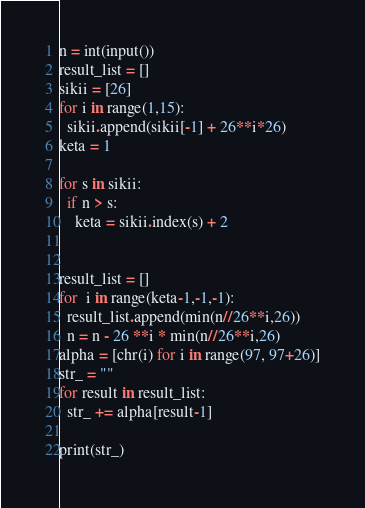Convert code to text. <code><loc_0><loc_0><loc_500><loc_500><_Python_>n = int(input())
result_list = []
sikii = [26]
for i in range(1,15):
  sikii.append(sikii[-1] + 26**i*26)
keta = 1

for s in sikii:
  if n > s:
    keta = sikii.index(s) + 2

    
result_list = []
for  i in range(keta-1,-1,-1):
  result_list.append(min(n//26**i,26))
  n = n - 26 **i * min(n//26**i,26)
alpha = [chr(i) for i in range(97, 97+26)]
str_ = ""
for result in result_list:
  str_ += alpha[result-1]
  
print(str_)</code> 